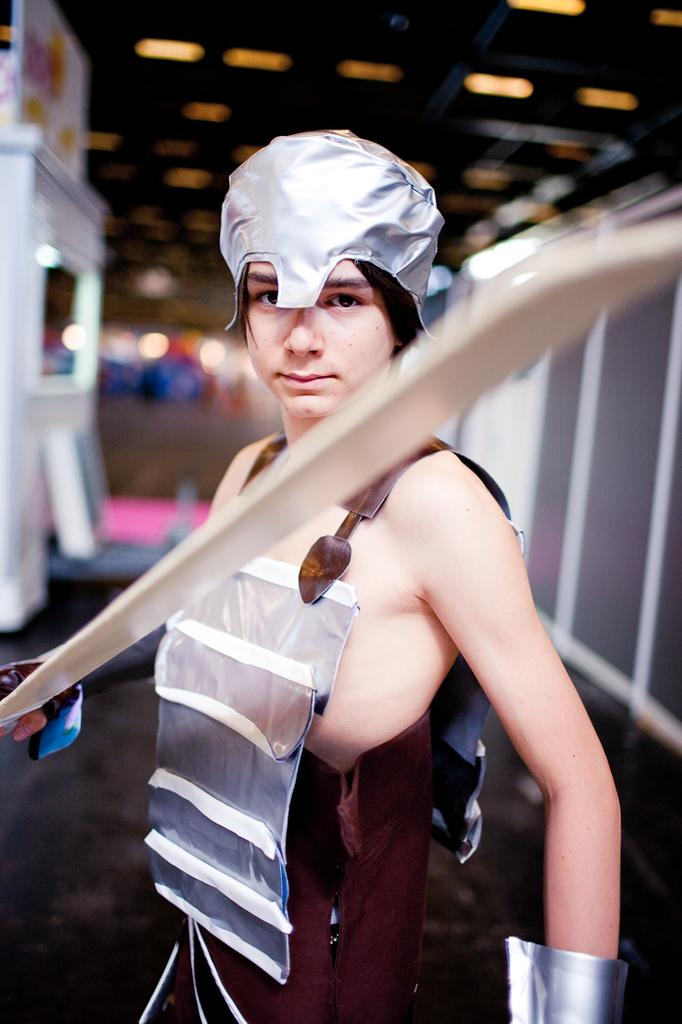What is the person in the image holding? The person in the image is holding a weapon. What can be seen on the roof in the image? There are light arrangements on the roof in the image. What type of music can be heard playing in the background of the image? There is no music present in the image, as it only shows a person holding a weapon and light arrangements on the roof. How does the friction between the weapon and the person's hand affect the image? The image does not provide any information about the friction between the weapon and the person's hand, as it only shows the person holding the weapon and light arrangements on the roof. 